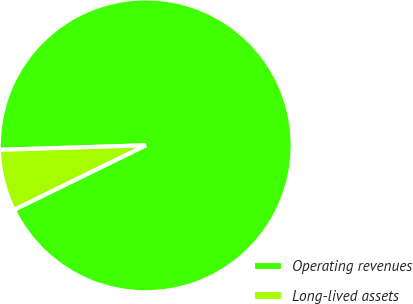<chart> <loc_0><loc_0><loc_500><loc_500><pie_chart><fcel>Operating revenues<fcel>Long-lived assets<nl><fcel>93.25%<fcel>6.75%<nl></chart> 